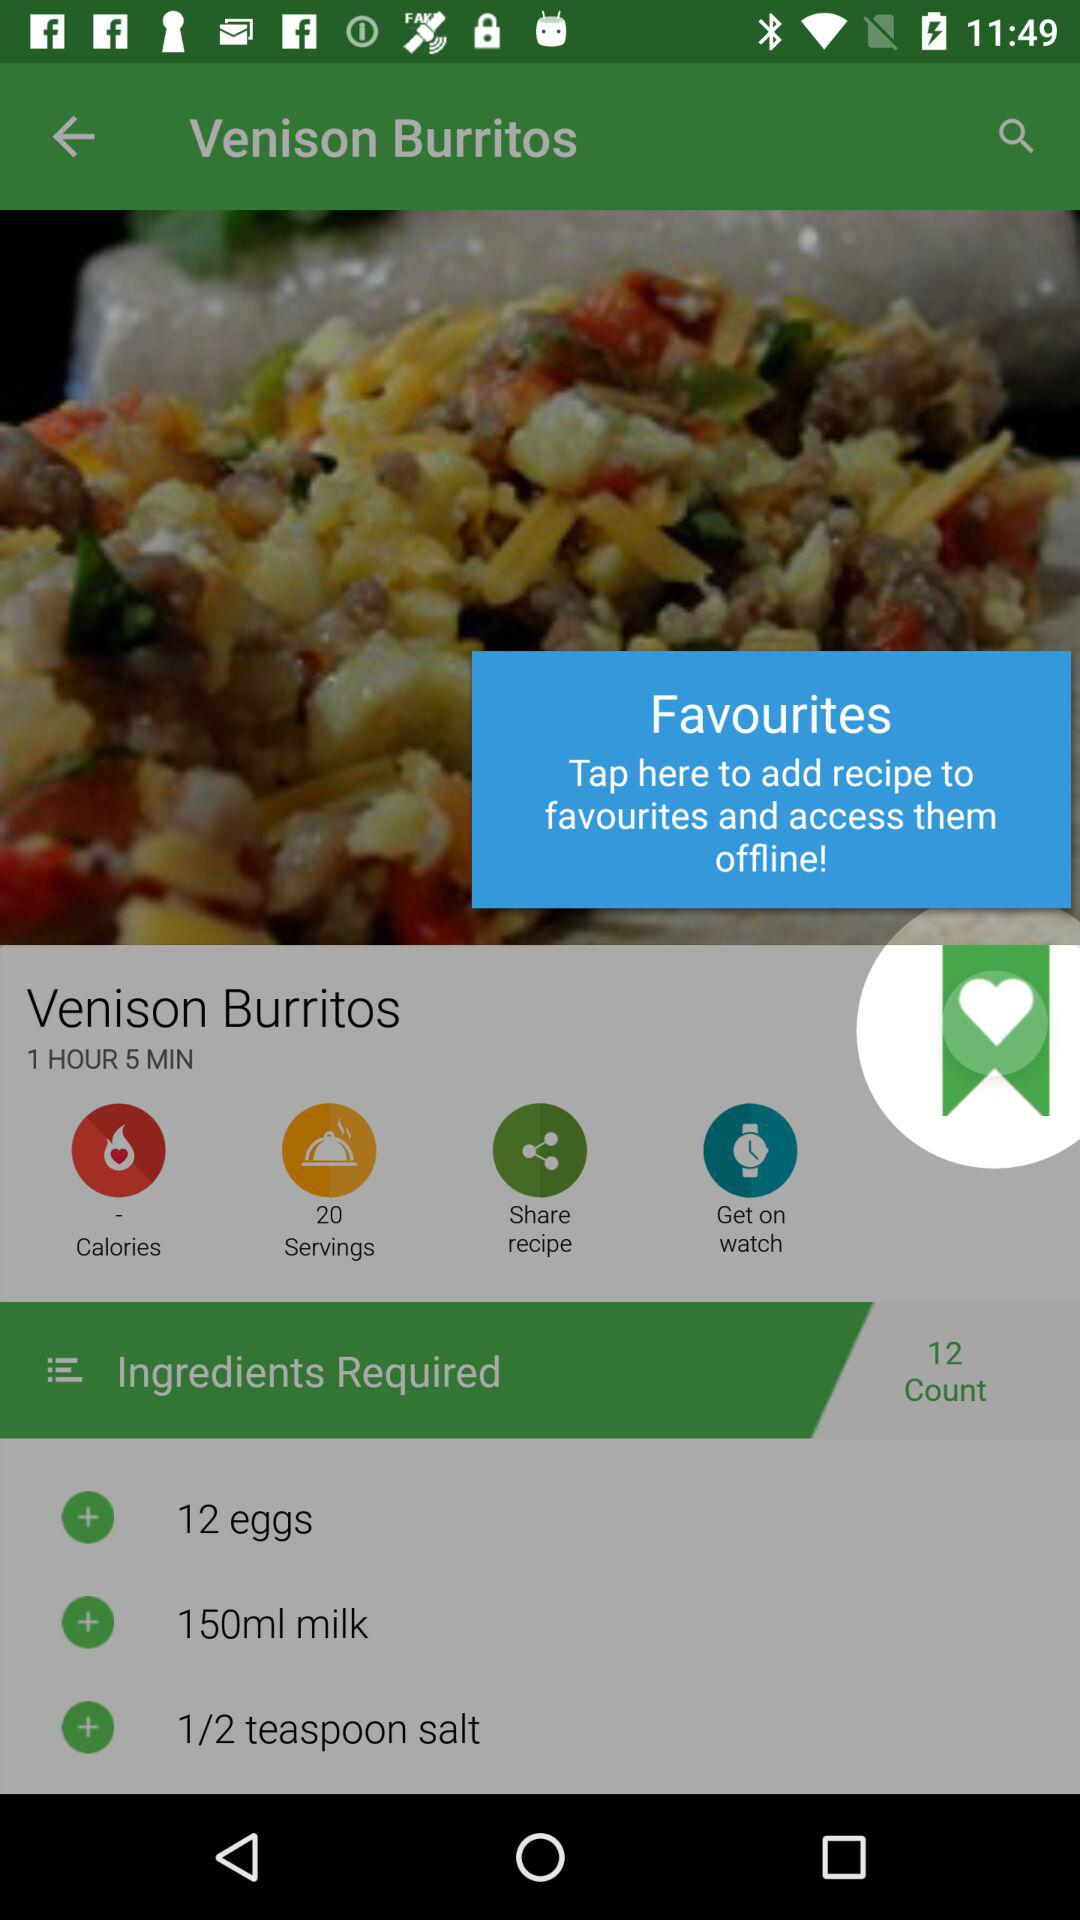How many servings does this recipe make?
Answer the question using a single word or phrase. 20 